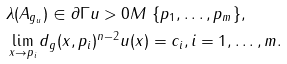Convert formula to latex. <formula><loc_0><loc_0><loc_500><loc_500>& \lambda ( A _ { g _ { u } } ) \in \partial \Gamma u > 0 M \ \{ p _ { 1 } , \dots , p _ { m } \} , \\ & \lim _ { x \rightarrow p _ { i } } d _ { g } ( x , p _ { i } ) ^ { n - 2 } u ( x ) = c _ { i } , i = 1 , \dots , m .</formula> 